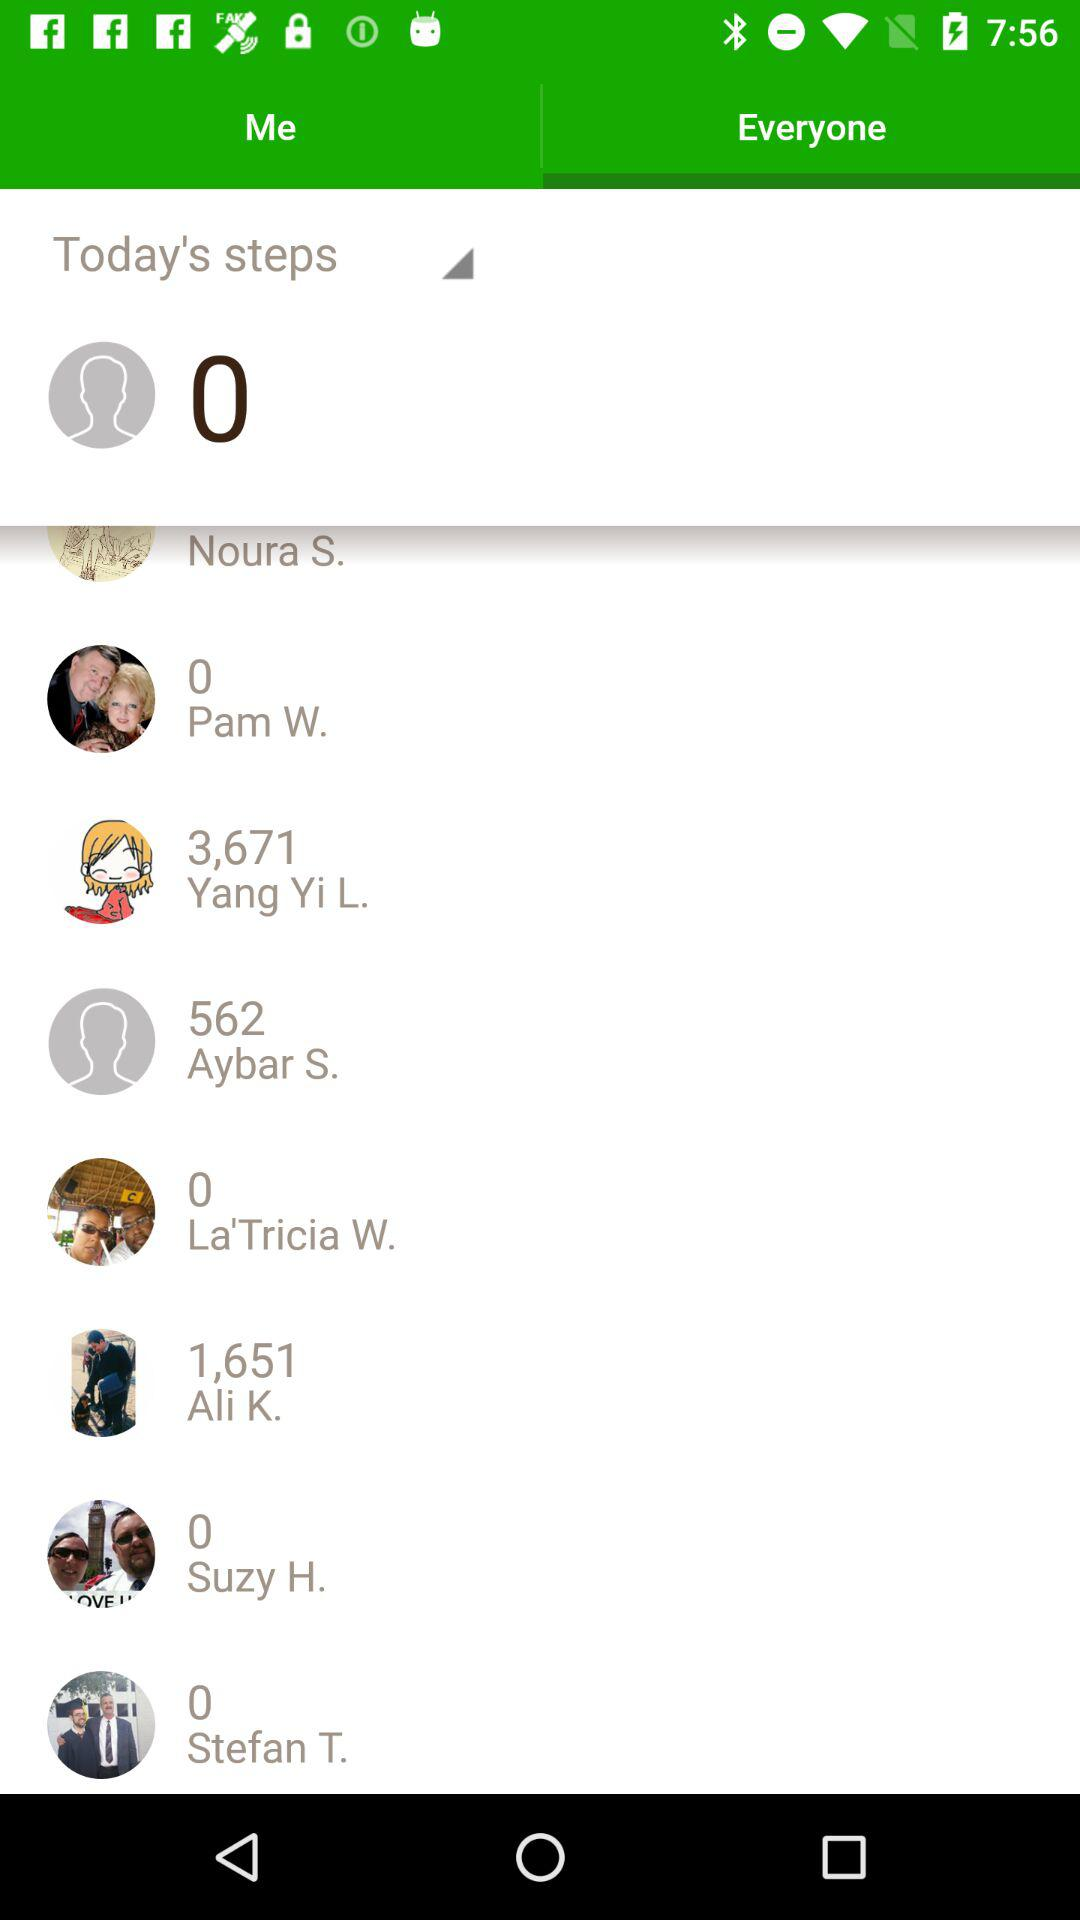What is the count of today's steps? The count is 0. 